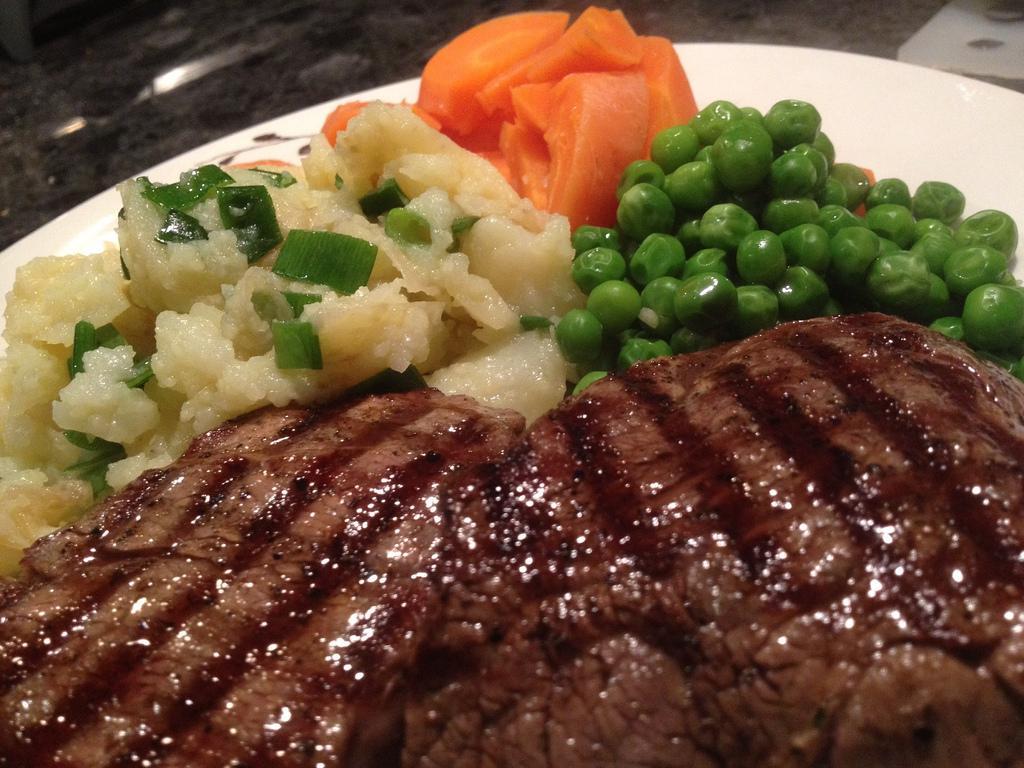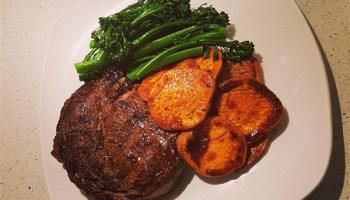The first image is the image on the left, the second image is the image on the right. For the images shown, is this caption "There are carrots on the plate in the image on the left." true? Answer yes or no. Yes. 